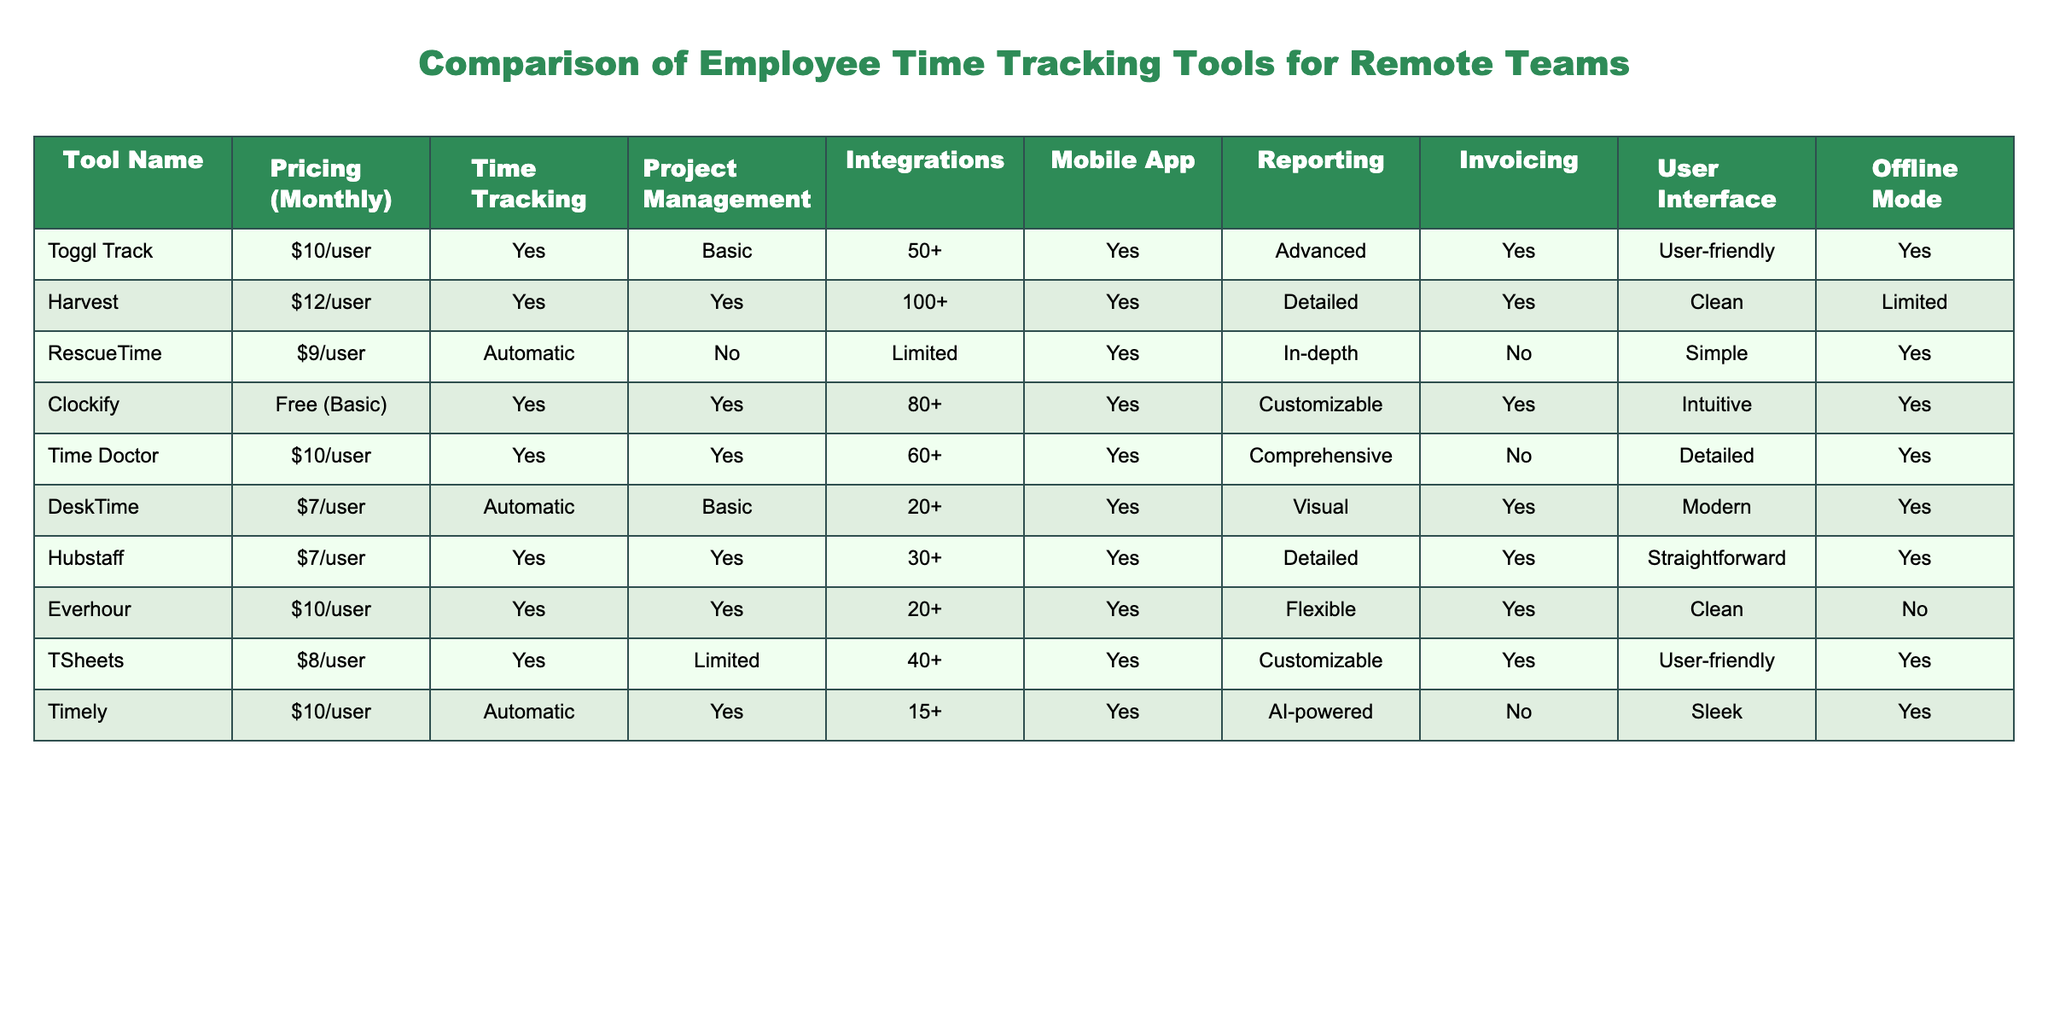What is the pricing for Clockify? The pricing for Clockify is stated in the table under the Pricing (Monthly) column for that tool. It shows "Free (Basic)".
Answer: Free (Basic) Which tools have advanced reporting features? To determine which tools have "Advanced" reporting, we check the Reporting column in the table. The tools Toggl Track and Time Doctor both have "Advanced" listed.
Answer: Toggl Track, Time Doctor Are there any tools that provide offline mode? We look at the Offline Mode column to check for "Yes" values. The tools listed with offline mode are Toggl Track, RescueTime, DeskTime, Hubstaff, TSheets, and Timely, making it six tools.
Answer: Yes Which tool has the most integrations available? By examining the Integrations column, we see that Harvest has 100+ integrations, which is the highest count listed in the table.
Answer: Harvest Is there any tool that offers invoicing capabilities without a mobile app? We need to look for a tool that has "Yes" under Invoicing and "No" under Mobile App. The only tool that fits this criterion is Time Doctor, since it does not have a mobile app but does provide invoicing.
Answer: Yes What is the average pricing for the tools that offer project management features? The tools that provide project management are Harvest, Clockify, Time Doctor, Everhour, and Hubstaff. Their pricing is $12, Free, $10, $10, and $7 respectively. We sum these amounts: 12 + 0 + 10 + 10 + 7 = 39. Since one tool is free, we divide by 4 to get the average, which is 39/4 = 9.75.
Answer: 9.75 Which tool provides automatic time tracking and has a mobile app? We need to find tools that have "Automatic" in the Time Tracking column and "Yes" in the Mobile App column. The tools with these features are RescueTime and Timely.
Answer: RescueTime, Timely What is the total number of tools that have both customizable reporting and invoicing capabilities? We first filter the tools with "Customizable" in Reporting, which are DeskTime and TSheets, and both also have "Yes" for Invoicing. Therefore, there are two tools meeting these criteria.
Answer: 2 How many tools do not have project management capabilities? We look for tools with "No" in the Project Management column. The tools without project management are RescueTime and DeskTime. Hence, there are two tools.
Answer: 2 